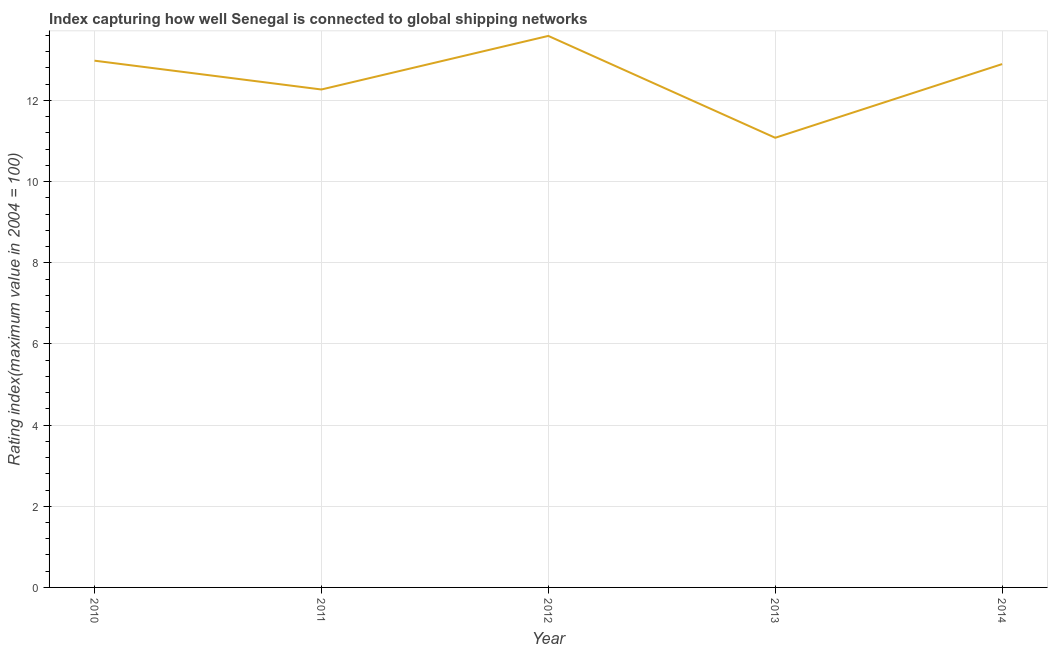What is the liner shipping connectivity index in 2011?
Ensure brevity in your answer.  12.27. Across all years, what is the maximum liner shipping connectivity index?
Ensure brevity in your answer.  13.59. Across all years, what is the minimum liner shipping connectivity index?
Ensure brevity in your answer.  11.08. What is the sum of the liner shipping connectivity index?
Provide a short and direct response. 62.82. What is the difference between the liner shipping connectivity index in 2011 and 2012?
Your response must be concise. -1.32. What is the average liner shipping connectivity index per year?
Make the answer very short. 12.56. What is the median liner shipping connectivity index?
Offer a very short reply. 12.9. In how many years, is the liner shipping connectivity index greater than 7.2 ?
Give a very brief answer. 5. What is the ratio of the liner shipping connectivity index in 2013 to that in 2014?
Ensure brevity in your answer.  0.86. Is the liner shipping connectivity index in 2011 less than that in 2012?
Offer a terse response. Yes. Is the difference between the liner shipping connectivity index in 2010 and 2011 greater than the difference between any two years?
Keep it short and to the point. No. What is the difference between the highest and the second highest liner shipping connectivity index?
Give a very brief answer. 0.61. Is the sum of the liner shipping connectivity index in 2010 and 2013 greater than the maximum liner shipping connectivity index across all years?
Keep it short and to the point. Yes. What is the difference between the highest and the lowest liner shipping connectivity index?
Give a very brief answer. 2.51. How many lines are there?
Your answer should be very brief. 1. What is the difference between two consecutive major ticks on the Y-axis?
Offer a very short reply. 2. Does the graph contain grids?
Your answer should be compact. Yes. What is the title of the graph?
Offer a very short reply. Index capturing how well Senegal is connected to global shipping networks. What is the label or title of the X-axis?
Your answer should be compact. Year. What is the label or title of the Y-axis?
Provide a succinct answer. Rating index(maximum value in 2004 = 100). What is the Rating index(maximum value in 2004 = 100) of 2010?
Your answer should be very brief. 12.98. What is the Rating index(maximum value in 2004 = 100) of 2011?
Offer a very short reply. 12.27. What is the Rating index(maximum value in 2004 = 100) in 2012?
Your answer should be compact. 13.59. What is the Rating index(maximum value in 2004 = 100) of 2013?
Keep it short and to the point. 11.08. What is the Rating index(maximum value in 2004 = 100) of 2014?
Your answer should be very brief. 12.9. What is the difference between the Rating index(maximum value in 2004 = 100) in 2010 and 2011?
Your answer should be compact. 0.71. What is the difference between the Rating index(maximum value in 2004 = 100) in 2010 and 2012?
Your answer should be very brief. -0.61. What is the difference between the Rating index(maximum value in 2004 = 100) in 2010 and 2014?
Offer a terse response. 0.08. What is the difference between the Rating index(maximum value in 2004 = 100) in 2011 and 2012?
Ensure brevity in your answer.  -1.32. What is the difference between the Rating index(maximum value in 2004 = 100) in 2011 and 2013?
Offer a very short reply. 1.19. What is the difference between the Rating index(maximum value in 2004 = 100) in 2011 and 2014?
Provide a succinct answer. -0.63. What is the difference between the Rating index(maximum value in 2004 = 100) in 2012 and 2013?
Give a very brief answer. 2.51. What is the difference between the Rating index(maximum value in 2004 = 100) in 2012 and 2014?
Provide a short and direct response. 0.69. What is the difference between the Rating index(maximum value in 2004 = 100) in 2013 and 2014?
Give a very brief answer. -1.82. What is the ratio of the Rating index(maximum value in 2004 = 100) in 2010 to that in 2011?
Your answer should be very brief. 1.06. What is the ratio of the Rating index(maximum value in 2004 = 100) in 2010 to that in 2012?
Offer a very short reply. 0.95. What is the ratio of the Rating index(maximum value in 2004 = 100) in 2010 to that in 2013?
Keep it short and to the point. 1.17. What is the ratio of the Rating index(maximum value in 2004 = 100) in 2010 to that in 2014?
Provide a succinct answer. 1.01. What is the ratio of the Rating index(maximum value in 2004 = 100) in 2011 to that in 2012?
Your answer should be compact. 0.9. What is the ratio of the Rating index(maximum value in 2004 = 100) in 2011 to that in 2013?
Offer a very short reply. 1.11. What is the ratio of the Rating index(maximum value in 2004 = 100) in 2011 to that in 2014?
Your response must be concise. 0.95. What is the ratio of the Rating index(maximum value in 2004 = 100) in 2012 to that in 2013?
Keep it short and to the point. 1.23. What is the ratio of the Rating index(maximum value in 2004 = 100) in 2012 to that in 2014?
Your answer should be compact. 1.05. What is the ratio of the Rating index(maximum value in 2004 = 100) in 2013 to that in 2014?
Give a very brief answer. 0.86. 